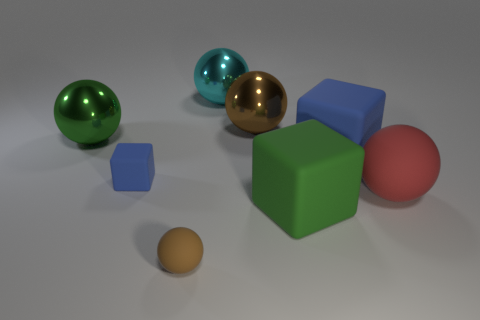Are there any large brown metallic objects that are on the right side of the blue cube that is right of the brown object that is to the right of the big cyan ball? No, there are no large brown metallic objects to the right of the blue cube. To the right of the blue cube is a space with no such objects present. 